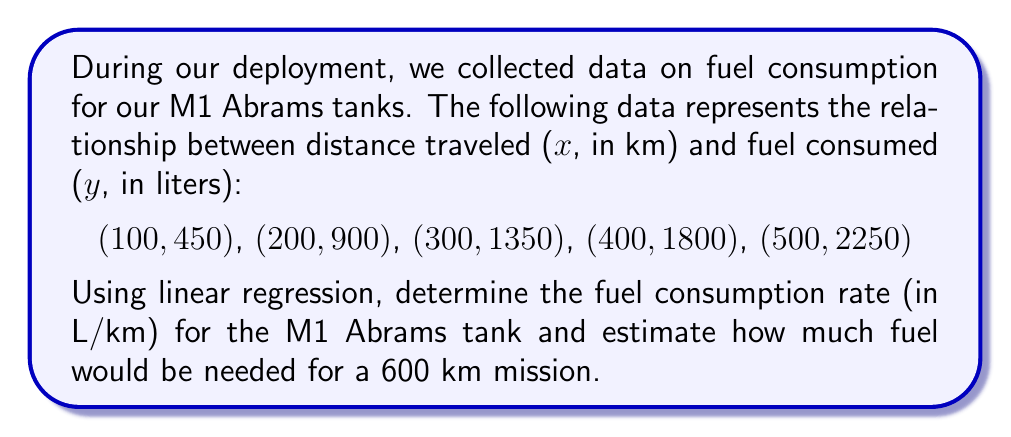Show me your answer to this math problem. Let's approach this step-by-step:

1) For linear regression, we use the formula: $y = mx + b$, where $m$ is the slope (fuel consumption rate) and $b$ is the y-intercept.

2) To find $m$, we use the formula:
   $$m = \frac{n\sum xy - \sum x \sum y}{n\sum x^2 - (\sum x)^2}$$

3) Calculate the necessary sums:
   $\sum x = 1500$, $\sum y = 6750$, $\sum xy = 3,375,000$, $\sum x^2 = 550,000$, $n = 5$

4) Plug into the formula:
   $$m = \frac{5(3,375,000) - (1500)(6750)}{5(550,000) - (1500)^2} = \frac{16,875,000 - 10,125,000}{2,750,000 - 2,250,000} = \frac{6,750,000}{500,000} = 4.5$$

5) The slope $m = 4.5$ L/km is our fuel consumption rate.

6) To find $b$, use the formula: $b = \bar{y} - m\bar{x}$
   $\bar{x} = 300$, $\bar{y} = 1350$
   $b = 1350 - 4.5(300) = 0$

7) Our regression equation is $y = 4.5x + 0$ or simply $y = 4.5x$

8) For a 600 km mission, plug into the equation:
   $y = 4.5(600) = 2700$ liters
Answer: 4.5 L/km; 2700 L for 600 km 